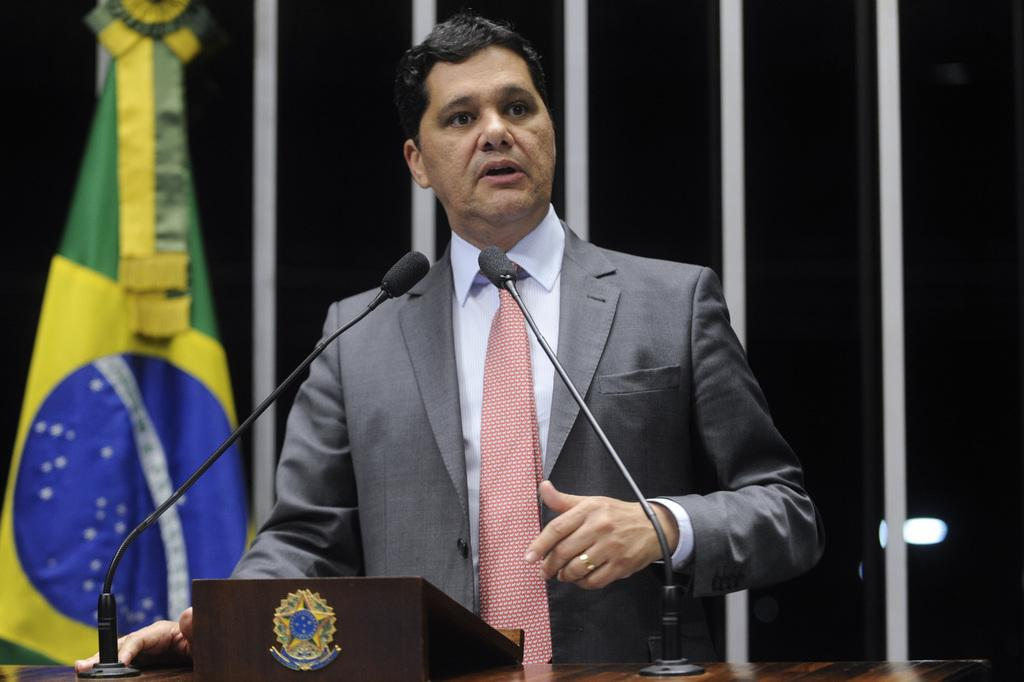What is the main subject of the image? There is a person in the image. What is the person wearing? The person is wearing a suit. What is the person doing in the image? The person is standing and speaking. What objects are in front of the person? There are two microphones in front of the person. What can be seen in the background of the image? There is a flag in the background of the image. What caption is written on the baseball in the image? There is no baseball present in the image, so there is no caption to be read. 